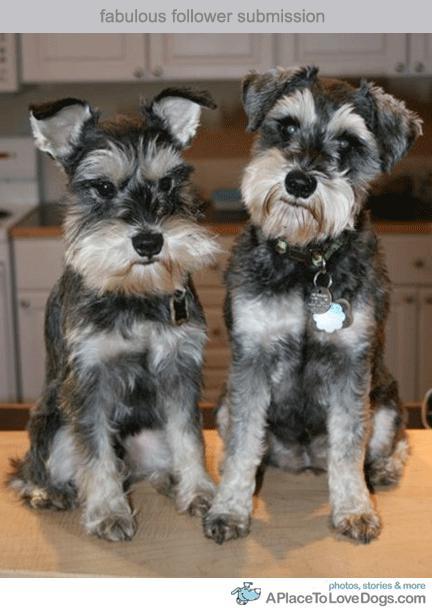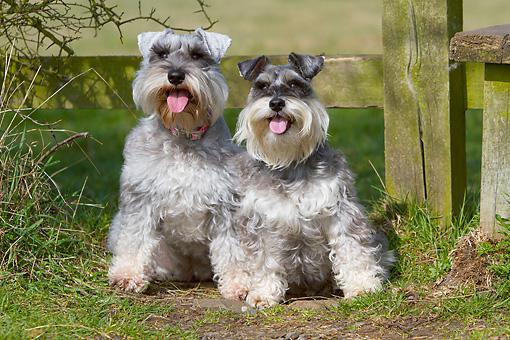The first image is the image on the left, the second image is the image on the right. Assess this claim about the two images: "There are two lighter colored dogs and two darker colored dogs.". Correct or not? Answer yes or no. Yes. The first image is the image on the left, the second image is the image on the right. Analyze the images presented: Is the assertion "Both images show side-by-side schnauzer dogs with faces that look ahead instead of at the side." valid? Answer yes or no. Yes. 